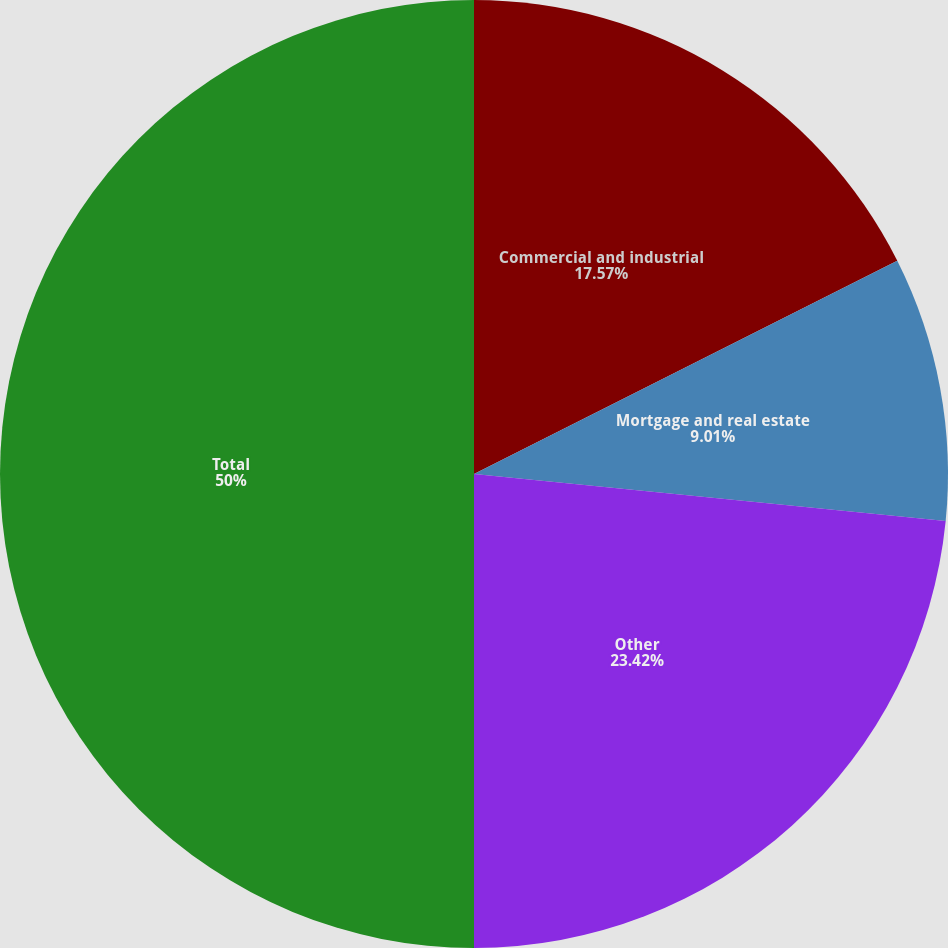<chart> <loc_0><loc_0><loc_500><loc_500><pie_chart><fcel>Commercial and industrial<fcel>Mortgage and real estate<fcel>Other<fcel>Total<nl><fcel>17.57%<fcel>9.01%<fcel>23.42%<fcel>50.0%<nl></chart> 